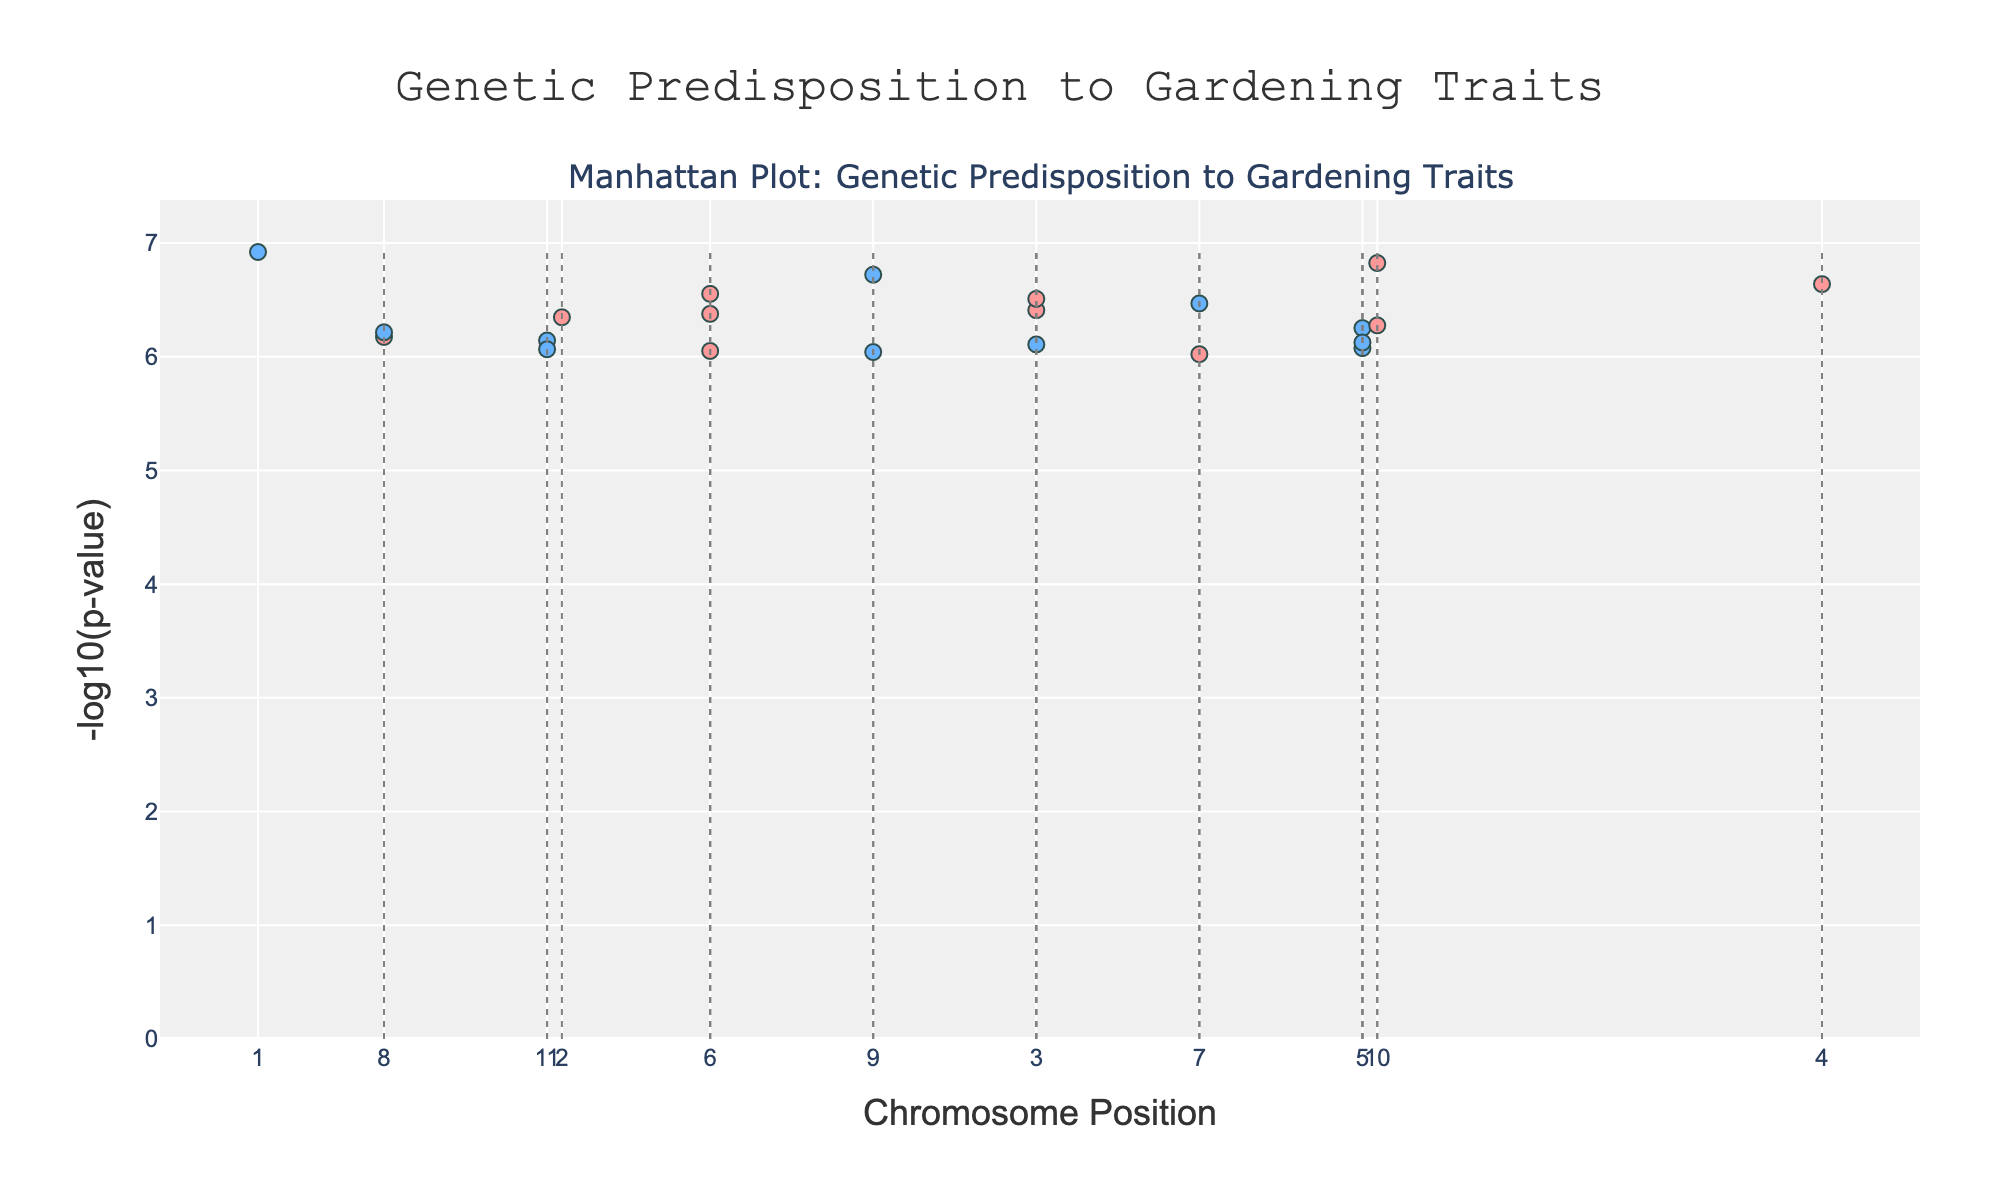What is the title of the figure? The title can be found at the top of the figure. The figure's title is "Genetic Predisposition to Gardening Traits"
Answer: Genetic Predisposition to Gardening Traits What do the colors of the markers represent? The colors of the markers represent alternating chromosomes. One color (light pink) represents even-numbered chromosomes and the other (light blue) represents odd-numbered chromosomes.
Answer: Chromosomes How many markers correspond to chromosome 8? To determine the number of markers for chromosome 8, we look at the distribution of markers along the x-axis and count those that fall under chromosome 8. In this case, there is 1 marker for chromosome 8.
Answer: 1 Which marker has the highest -log10(p-value), and what trait does it represent? The marker with the highest -log10(p-value) will be the highest point on the y-axis. This marker represents the "Plant care ability" trait and is associated with the RARG gene on chromosome 1.
Answer: Plant care ability (RARG on chromosome 1) What is the -log10(p-value) of the marker associated with Hydroponics enthusiasm? To find the -log10(p-value) of the marker related to Hydroponics enthusiasm, we locate the corresponding marker and its vertical position on the y-axis. The marker corresponds to SLC6A3 on chromosome 16 with a -log10(p-value) around 9.72.
Answer: 9.72 Which chromosomes are separated by dashed lines? Dashed lines are used to demarcate the different chromosomes. To find the chromosomes at the start of each dashed line, we observe where the lines are located along the x-axis. The chromosomes adjacent to dashed lines include every chromosome transition, e.g., between chromosomes 1 and 2, 2 and 3, etc.
Answer: Chromosome transitions (e.g., 1 and 2, 2 and 3, etc.) Compare the -log10(p-value) of markers for Organic gardening interest and Vertical gardening aptitude. Which one is higher? First, identify the markers for Organic gardening interest and Vertical gardening aptitude. The former is DRD4 on chromosome 11, and the latter is ALDH2 on chromosome 20. By comparing their y-axis positions, the marker for Organic gardening interest has a higher -log10(p-value).
Answer: Organic gardening interest (DRD4) What is the mean -log10(p-value) of the markers on chromosome 5? To find this, we first identify the -log10(p-value) for any markers on chromosome 5 (MC1R) and then calculate the mean. For chromosome 5, the -log10(p-value) is approximately 9.25. Since there's only one marker, the mean is 9.25.
Answer: 9.25 Which gene associated with Succulent care aptitude appears on the plot, and what chromosome is it on? Locate the trait "Succulent care aptitude" on the figure, then identify the corresponding gene and chromosome. According to the data, the gene is MC1R, and it is on chromosome 5.
Answer: MC1R on chromosome 5 In terms of -log10(p-value), how does the marker for Pollinator-friendly gardening compare to Herb cultivation interest? The marker for Pollinator-friendly gardening is OPRM1 on chromosome 22, and for Herb cultivation interest, it is FTO on chromosome 4. The -log10(p-value) for Pollinator-friendly gardening is lower than for Herb cultivation interest.
Answer: Herb cultivation interest is higher 